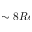<formula> <loc_0><loc_0><loc_500><loc_500>\sim 8 R e</formula> 